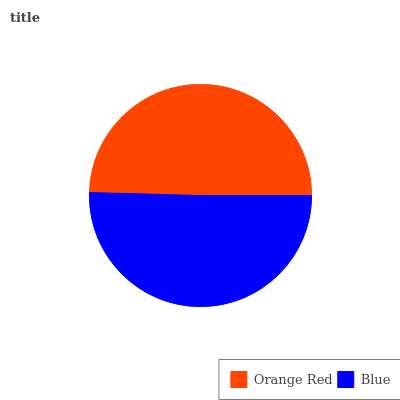Is Orange Red the minimum?
Answer yes or no. Yes. Is Blue the maximum?
Answer yes or no. Yes. Is Blue the minimum?
Answer yes or no. No. Is Blue greater than Orange Red?
Answer yes or no. Yes. Is Orange Red less than Blue?
Answer yes or no. Yes. Is Orange Red greater than Blue?
Answer yes or no. No. Is Blue less than Orange Red?
Answer yes or no. No. Is Blue the high median?
Answer yes or no. Yes. Is Orange Red the low median?
Answer yes or no. Yes. Is Orange Red the high median?
Answer yes or no. No. Is Blue the low median?
Answer yes or no. No. 